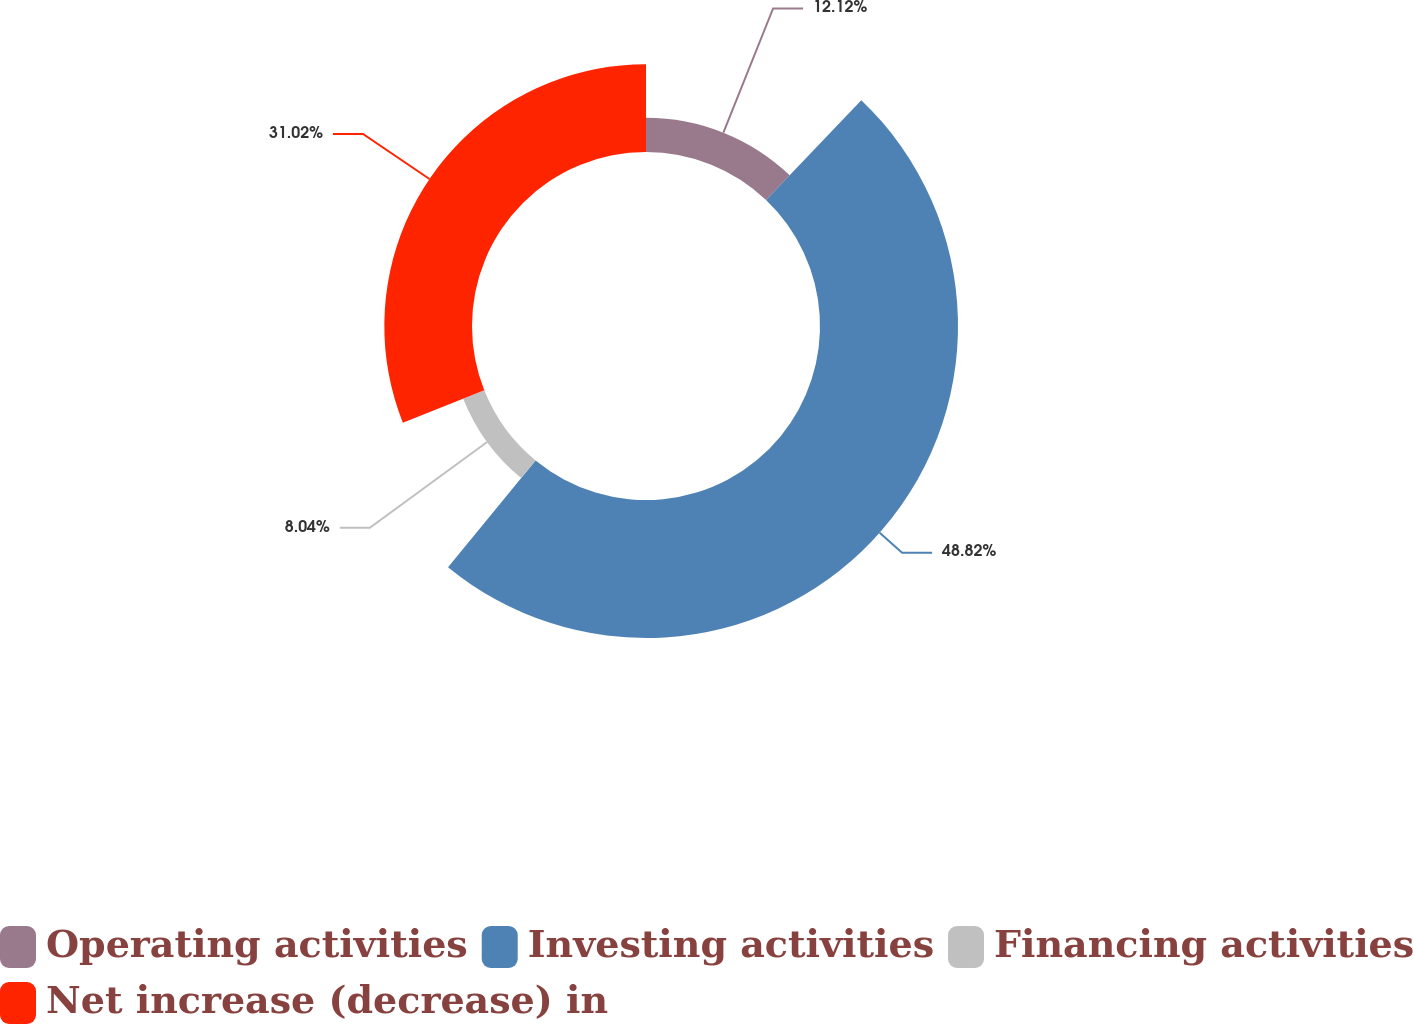<chart> <loc_0><loc_0><loc_500><loc_500><pie_chart><fcel>Operating activities<fcel>Investing activities<fcel>Financing activities<fcel>Net increase (decrease) in<nl><fcel>12.12%<fcel>48.82%<fcel>8.04%<fcel>31.02%<nl></chart> 